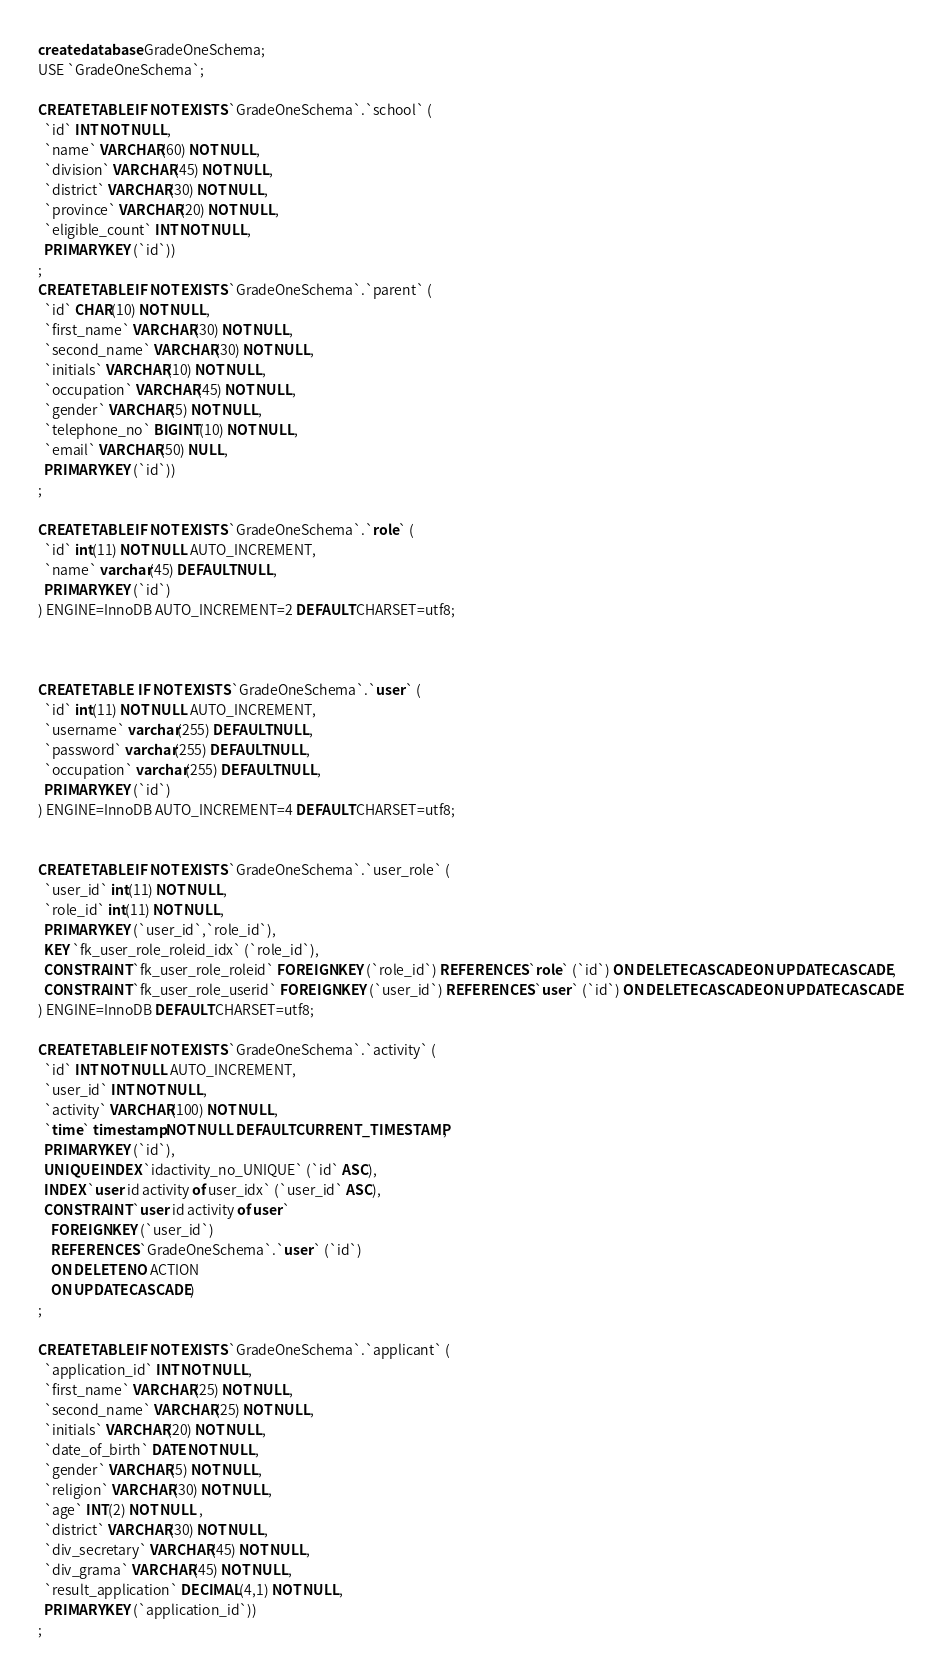Convert code to text. <code><loc_0><loc_0><loc_500><loc_500><_SQL_>create database GradeOneSchema;
USE `GradeOneSchema`;
		            
CREATE TABLE IF NOT EXISTS `GradeOneSchema`.`school` (
  `id` INT NOT NULL,
  `name` VARCHAR(60) NOT NULL,
  `division` VARCHAR(45) NOT NULL,
  `district` VARCHAR(30) NOT NULL,
  `province` VARCHAR(20) NOT NULL,
  `eligible_count` INT NOT NULL,
  PRIMARY KEY (`id`))
;
CREATE TABLE IF NOT EXISTS `GradeOneSchema`.`parent` (
  `id` CHAR(10) NOT NULL,
  `first_name` VARCHAR(30) NOT NULL,
  `second_name` VARCHAR(30) NOT NULL,
  `initials` VARCHAR(10) NOT NULL,
  `occupation` VARCHAR(45) NOT NULL,
  `gender` VARCHAR(5) NOT NULL,
  `telephone_no` BIGINT(10) NOT NULL,
  `email` VARCHAR(50) NULL,
  PRIMARY KEY (`id`))
;

CREATE TABLE IF NOT EXISTS `GradeOneSchema`.`role` (
  `id` int(11) NOT NULL AUTO_INCREMENT,
  `name` varchar(45) DEFAULT NULL,
  PRIMARY KEY (`id`)
) ENGINE=InnoDB AUTO_INCREMENT=2 DEFAULT CHARSET=utf8;



CREATE TABLE  IF NOT EXISTS `GradeOneSchema`.`user` (
  `id` int(11) NOT NULL AUTO_INCREMENT,
  `username` varchar(255) DEFAULT NULL,
  `password` varchar(255) DEFAULT NULL,
  `occupation` varchar(255) DEFAULT NULL,
  PRIMARY KEY (`id`)
) ENGINE=InnoDB AUTO_INCREMENT=4 DEFAULT CHARSET=utf8;


CREATE TABLE IF NOT EXISTS `GradeOneSchema`.`user_role` (
  `user_id` int(11) NOT NULL,
  `role_id` int(11) NOT NULL,
  PRIMARY KEY (`user_id`,`role_id`),
  KEY `fk_user_role_roleid_idx` (`role_id`),
  CONSTRAINT `fk_user_role_roleid` FOREIGN KEY (`role_id`) REFERENCES `role` (`id`) ON DELETE CASCADE ON UPDATE CASCADE,
  CONSTRAINT `fk_user_role_userid` FOREIGN KEY (`user_id`) REFERENCES `user` (`id`) ON DELETE CASCADE ON UPDATE CASCADE
) ENGINE=InnoDB DEFAULT CHARSET=utf8;

CREATE TABLE IF NOT EXISTS `GradeOneSchema`.`activity` (
  `id` INT NOT NULL AUTO_INCREMENT,
  `user_id` INT NOT NULL,
  `activity` VARCHAR(100) NOT NULL,
  `time` timestamp NOT NULL DEFAULT CURRENT_TIMESTAMP,
  PRIMARY KEY (`id`),
  UNIQUE INDEX `idactivity_no_UNIQUE` (`id` ASC),
  INDEX `user id activity of user_idx` (`user_id` ASC),
  CONSTRAINT `user id activity of user`
    FOREIGN KEY (`user_id`)
    REFERENCES `GradeOneSchema`.`user` (`id`)
    ON DELETE NO ACTION
    ON UPDATE CASCADE)
;

CREATE TABLE IF NOT EXISTS `GradeOneSchema`.`applicant` (
  `application_id` INT NOT NULL,
  `first_name` VARCHAR(25) NOT NULL,
  `second_name` VARCHAR(25) NOT NULL,
  `initials` VARCHAR(20) NOT NULL,
  `date_of_birth` DATE NOT NULL,
  `gender` VARCHAR(5) NOT NULL,
  `religion` VARCHAR(30) NOT NULL,
  `age` INT(2) NOT NULL ,
  `district` VARCHAR(30) NOT NULL,
  `div_secretary` VARCHAR(45) NOT NULL,
  `div_grama` VARCHAR(45) NOT NULL,
  `result_application` DECIMAL(4,1) NOT NULL,
  PRIMARY KEY (`application_id`))
;
</code> 